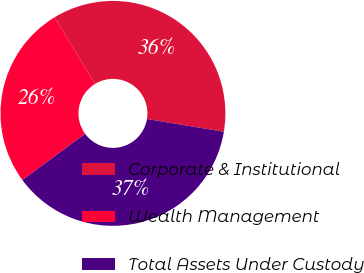Convert chart to OTSL. <chart><loc_0><loc_0><loc_500><loc_500><pie_chart><fcel>Corporate & Institutional<fcel>Wealth Management<fcel>Total Assets Under Custody<nl><fcel>36.3%<fcel>26.4%<fcel>37.29%<nl></chart> 